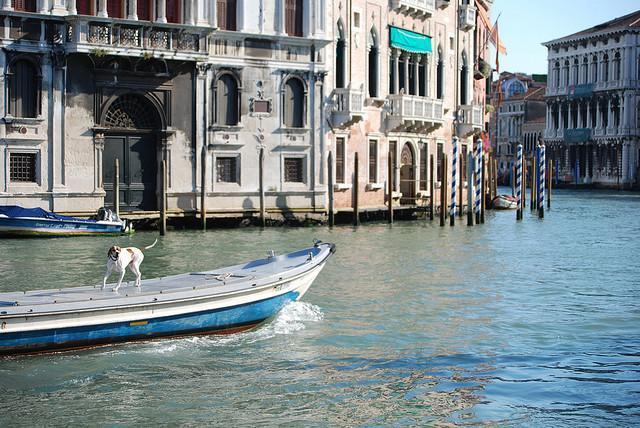How many boats are in the photo?
Give a very brief answer. 2. 